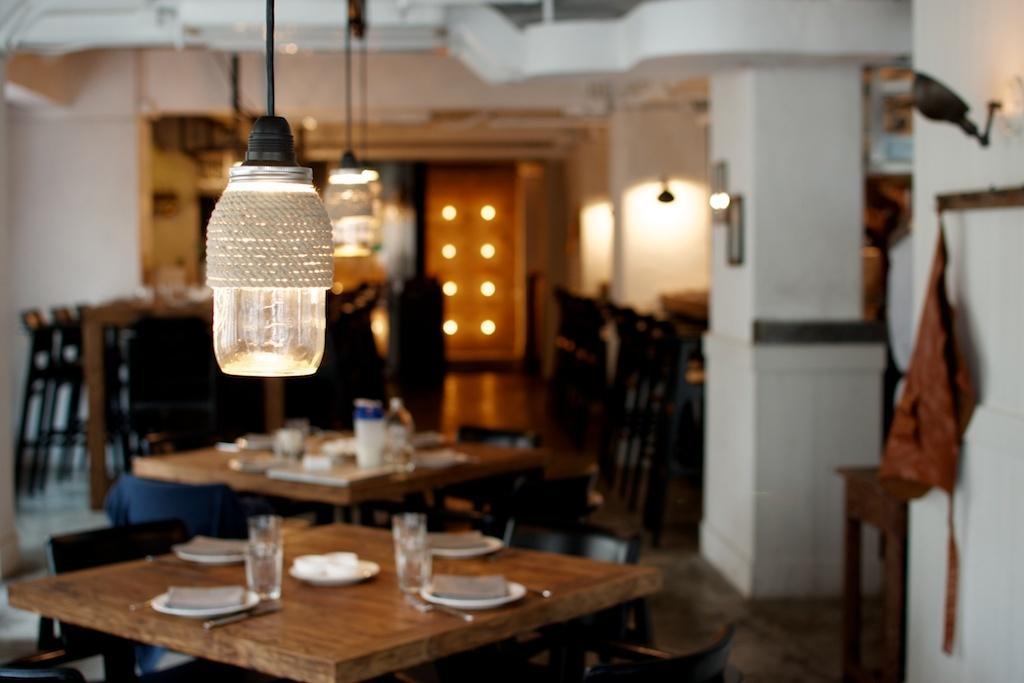How would you summarize this image in a sentence or two? This image is blurred. In the image we can see there are tables and chairs, on the table there are glasses, plates and spoons. This is a pillar, floor and light. 